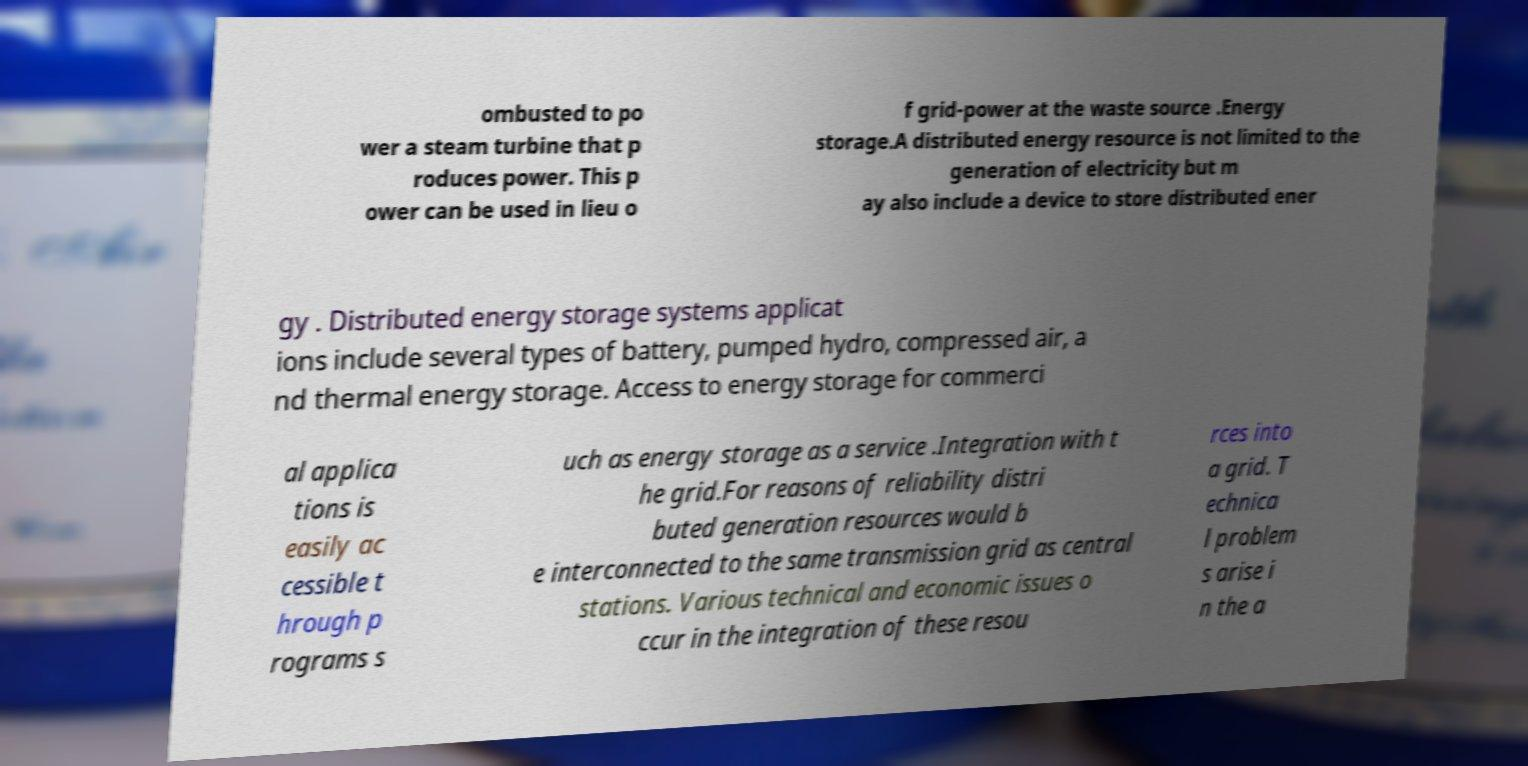Could you assist in decoding the text presented in this image and type it out clearly? ombusted to po wer a steam turbine that p roduces power. This p ower can be used in lieu o f grid-power at the waste source .Energy storage.A distributed energy resource is not limited to the generation of electricity but m ay also include a device to store distributed ener gy . Distributed energy storage systems applicat ions include several types of battery, pumped hydro, compressed air, a nd thermal energy storage. Access to energy storage for commerci al applica tions is easily ac cessible t hrough p rograms s uch as energy storage as a service .Integration with t he grid.For reasons of reliability distri buted generation resources would b e interconnected to the same transmission grid as central stations. Various technical and economic issues o ccur in the integration of these resou rces into a grid. T echnica l problem s arise i n the a 